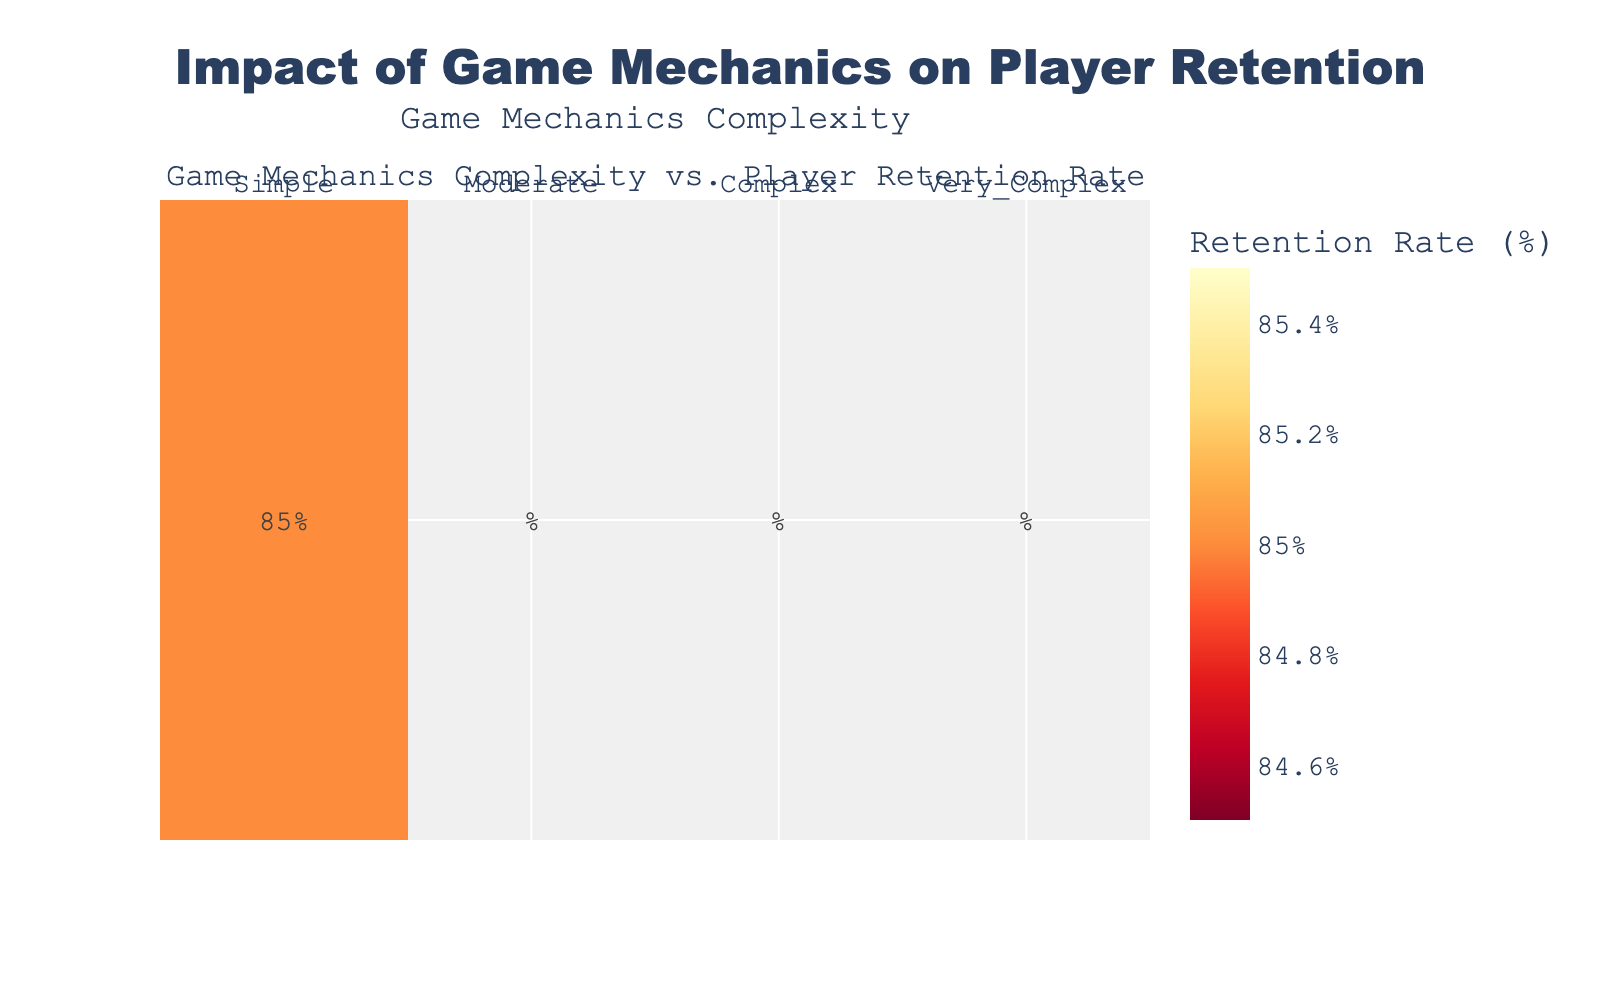1. What is the title of the heatmap? The title of the heatmap is displayed at the top of the figure. It states the main subject of the plot.
Answer: Impact of Game Mechanics on Player Retention 2. What color scheme is used in the heatmap? The color scheme is indicative of the retention rates, moving from lighter to darker shades. It uses a colorscale to show different ranges of retention rates.
Answer: YlOrRd_r 3. What is the average player retention rate for games with "Complex" game mechanics? Identify the average value from the heatmap cell corresponding to "Complex" game mechanics complexity.
Answer: 62.3% 4. How does player retention rate change as game mechanics complexity increases? Observe the trend from lower to higher complexity in the heatmap. Retention rate decreases as complexity increases.
Answer: Decreases 5. Among "Simple" and "Moderate" game mechanics, which category has a higher average retention rate? Look at the retention rates for both "Simple" and "Moderate" categories. "Simple" has higher average retention.
Answer: Simple 6. What is the retention rate difference between "Simple" and "Very Complex" game mechanics? Look at the average retention rates for "Simple" and "Very Complex", then calculate the difference. "Simple" (85%) - "Very Complex" (52.3%) = 32.7%.
Answer: 32.7% 7. Which game mechanics complexity has the lowest player retention rate? Identify the category with the lowest average retention rate from the heatmap, which is "Very Complex".
Answer: Very Complex 8. If a game designer aims for a retention rate of at least 70%, which categories of game mechanics should they consider avoiding? Look at the categories in the heatmap where the average retention rate is below 70%. Those are "Complex" and "Very Complex".
Answer: Complex, Very Complex 9. What would you infer about the correlation between game mechanics complexity and player retention rate based on the heatmap? By observing the trend in the heatmap, you can infer that as game mechanics become more complex, the retention rate tends to decrease.
Answer: Negative correlation 10. How much lower is the retention rate for "Moderate" game mechanics compared to "Simple"? Look at the average retention rates for "Moderate" (75%) and "Simple" (85%), then calculate the difference.
Answer: 10% 